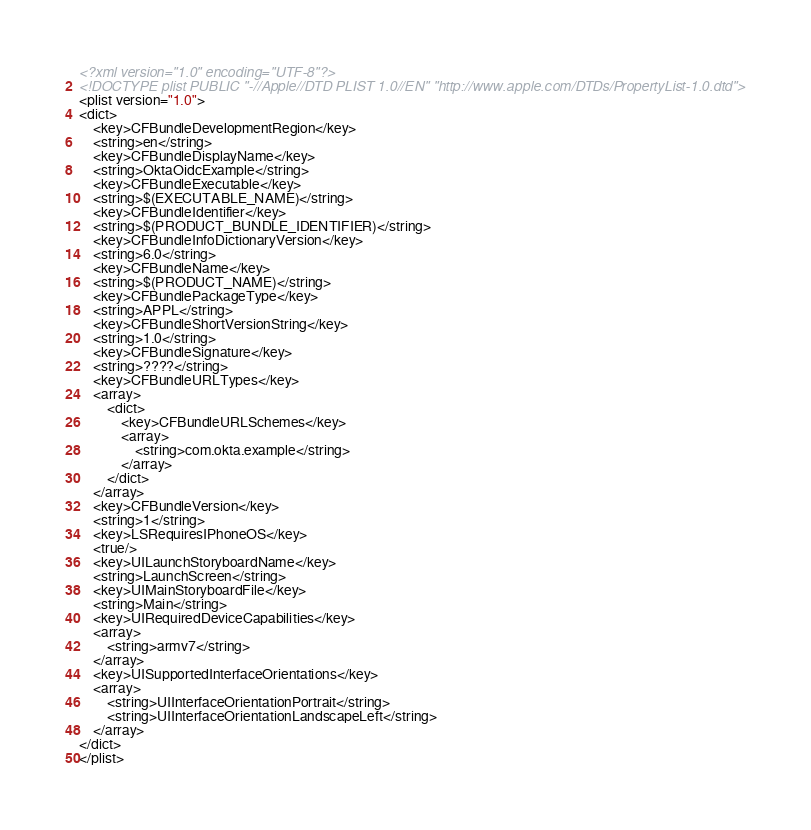<code> <loc_0><loc_0><loc_500><loc_500><_XML_><?xml version="1.0" encoding="UTF-8"?>
<!DOCTYPE plist PUBLIC "-//Apple//DTD PLIST 1.0//EN" "http://www.apple.com/DTDs/PropertyList-1.0.dtd">
<plist version="1.0">
<dict>
	<key>CFBundleDevelopmentRegion</key>
	<string>en</string>
	<key>CFBundleDisplayName</key>
	<string>OktaOidcExample</string>
	<key>CFBundleExecutable</key>
	<string>$(EXECUTABLE_NAME)</string>
	<key>CFBundleIdentifier</key>
	<string>$(PRODUCT_BUNDLE_IDENTIFIER)</string>
	<key>CFBundleInfoDictionaryVersion</key>
	<string>6.0</string>
	<key>CFBundleName</key>
	<string>$(PRODUCT_NAME)</string>
	<key>CFBundlePackageType</key>
	<string>APPL</string>
	<key>CFBundleShortVersionString</key>
	<string>1.0</string>
	<key>CFBundleSignature</key>
	<string>????</string>
	<key>CFBundleURLTypes</key>
	<array>
		<dict>
			<key>CFBundleURLSchemes</key>
			<array>
				<string>com.okta.example</string>
			</array>
		</dict>
	</array>
	<key>CFBundleVersion</key>
	<string>1</string>
	<key>LSRequiresIPhoneOS</key>
	<true/>
	<key>UILaunchStoryboardName</key>
	<string>LaunchScreen</string>
	<key>UIMainStoryboardFile</key>
	<string>Main</string>
	<key>UIRequiredDeviceCapabilities</key>
	<array>
		<string>armv7</string>
	</array>
	<key>UISupportedInterfaceOrientations</key>
	<array>
		<string>UIInterfaceOrientationPortrait</string>
		<string>UIInterfaceOrientationLandscapeLeft</string>
	</array>
</dict>
</plist>
</code> 